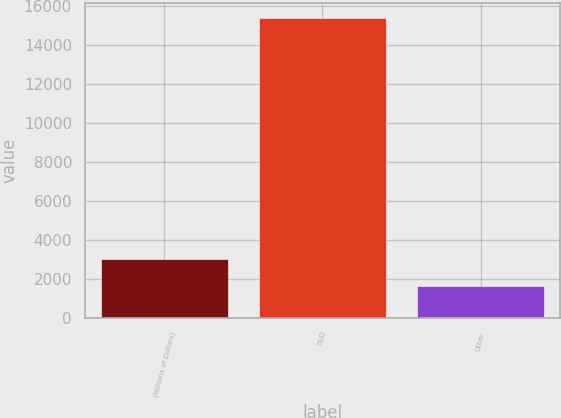Convert chart. <chart><loc_0><loc_0><loc_500><loc_500><bar_chart><fcel>(Millions of Dollars)<fcel>T&D<fcel>Other<nl><fcel>3026.4<fcel>15414<fcel>1650<nl></chart> 